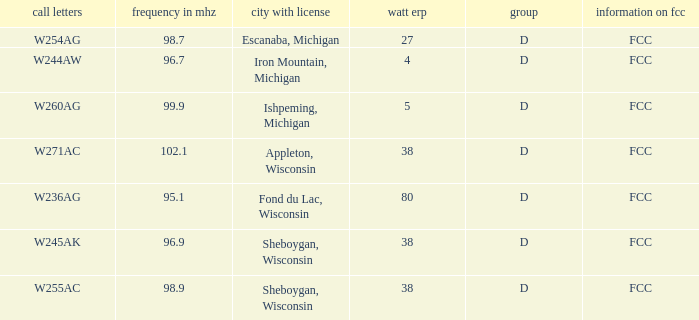What was the ERP W for 96.7 MHz? 4.0. 